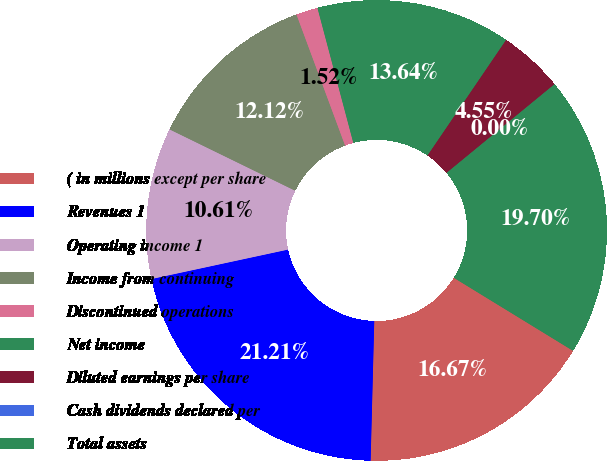<chart> <loc_0><loc_0><loc_500><loc_500><pie_chart><fcel>( in millions except per share<fcel>Revenues 1<fcel>Operating income 1<fcel>Income from continuing<fcel>Discontinued operations<fcel>Net income<fcel>Diluted earnings per share<fcel>Cash dividends declared per<fcel>Total assets<nl><fcel>16.67%<fcel>21.21%<fcel>10.61%<fcel>12.12%<fcel>1.52%<fcel>13.64%<fcel>4.55%<fcel>0.0%<fcel>19.7%<nl></chart> 